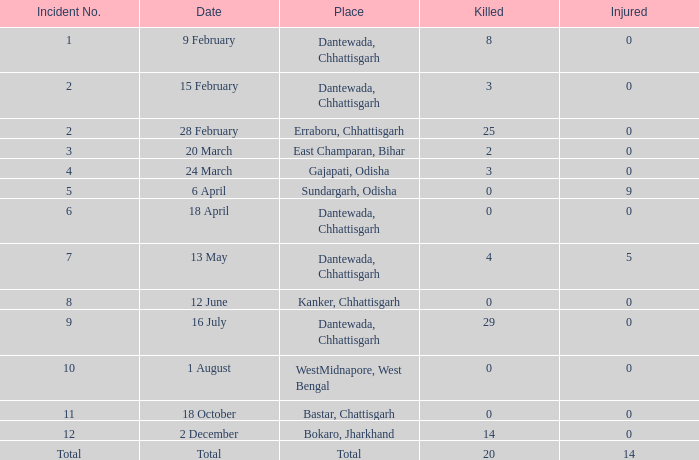In east champaran, bihar, how many people were hurt in total when more than 2 people lost their lives? 0.0. 